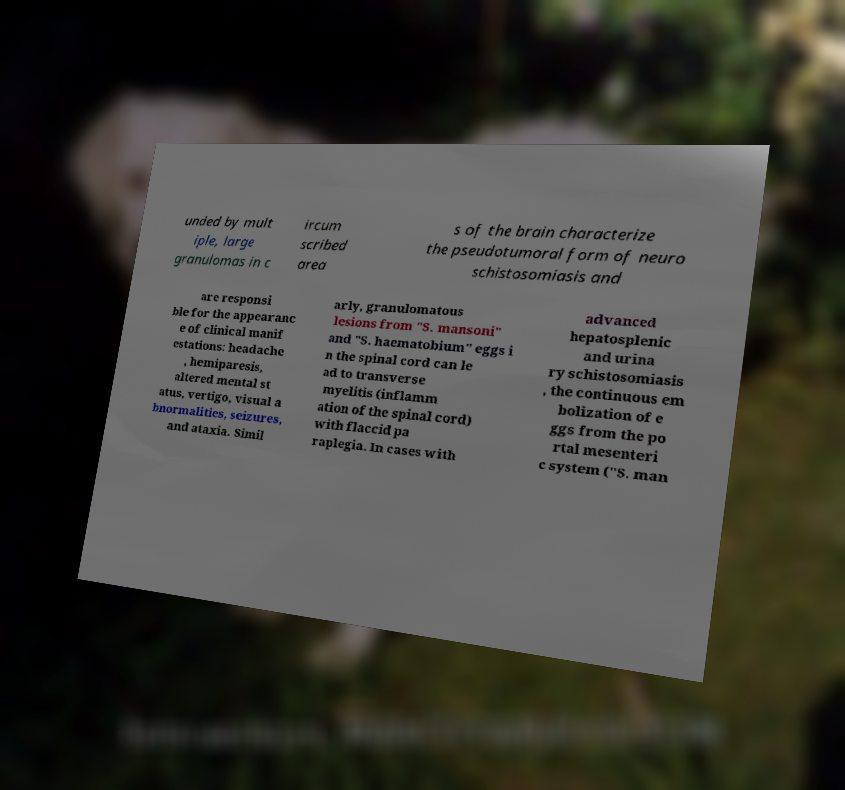Can you read and provide the text displayed in the image?This photo seems to have some interesting text. Can you extract and type it out for me? unded by mult iple, large granulomas in c ircum scribed area s of the brain characterize the pseudotumoral form of neuro schistosomiasis and are responsi ble for the appearanc e of clinical manif estations: headache , hemiparesis, altered mental st atus, vertigo, visual a bnormalities, seizures, and ataxia. Simil arly, granulomatous lesions from "S. mansoni" and "S. haematobium" eggs i n the spinal cord can le ad to transverse myelitis (inflamm ation of the spinal cord) with flaccid pa raplegia. In cases with advanced hepatosplenic and urina ry schistosomiasis , the continuous em bolization of e ggs from the po rtal mesenteri c system ("S. man 